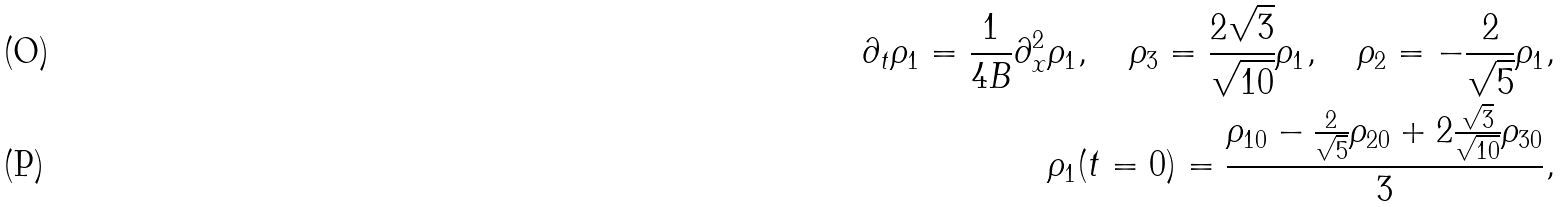<formula> <loc_0><loc_0><loc_500><loc_500>\partial _ { t } \rho _ { 1 } = \frac { 1 } { 4 B } \partial _ { x } ^ { 2 } \rho _ { 1 } , \quad \rho _ { 3 } = \frac { 2 \sqrt { 3 } } { \sqrt { 1 0 } } \rho _ { 1 } , \quad \rho _ { 2 } = - \frac { 2 } { \sqrt { 5 } } \rho _ { 1 } , \\ \rho _ { 1 } ( t = 0 ) = \frac { \rho _ { 1 0 } - \frac { 2 } { \sqrt { 5 } } \rho _ { 2 0 } + 2 \frac { \sqrt { 3 } } { \sqrt { 1 0 } } \rho _ { 3 0 } } { 3 } ,</formula> 